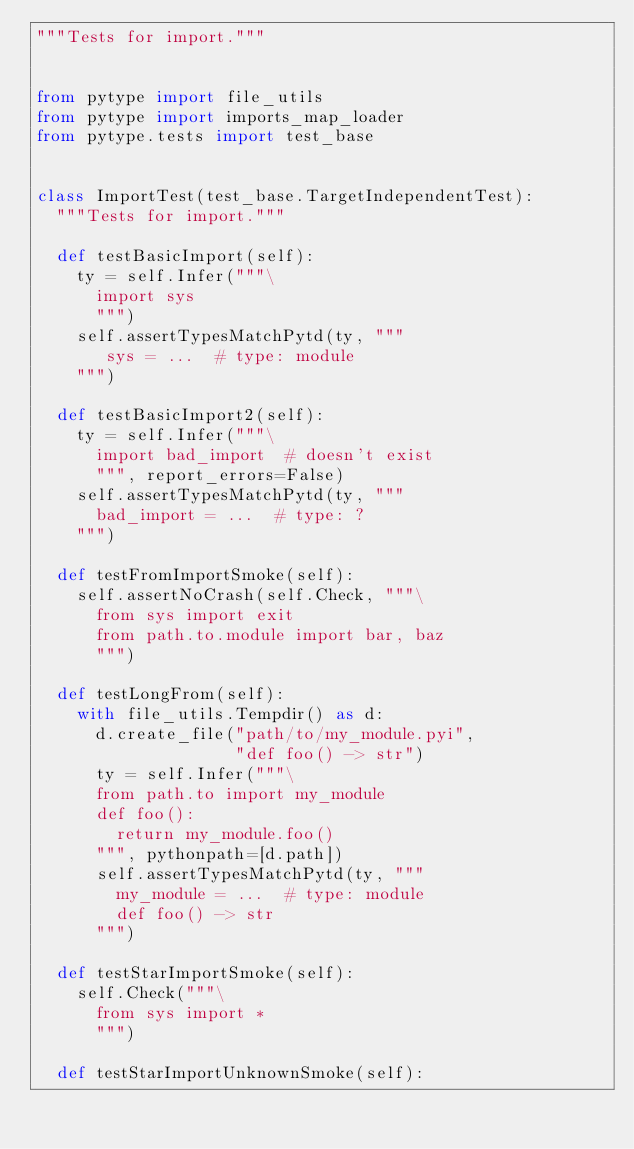<code> <loc_0><loc_0><loc_500><loc_500><_Python_>"""Tests for import."""


from pytype import file_utils
from pytype import imports_map_loader
from pytype.tests import test_base


class ImportTest(test_base.TargetIndependentTest):
  """Tests for import."""

  def testBasicImport(self):
    ty = self.Infer("""\
      import sys
      """)
    self.assertTypesMatchPytd(ty, """
       sys = ...  # type: module
    """)

  def testBasicImport2(self):
    ty = self.Infer("""\
      import bad_import  # doesn't exist
      """, report_errors=False)
    self.assertTypesMatchPytd(ty, """
      bad_import = ...  # type: ?
    """)

  def testFromImportSmoke(self):
    self.assertNoCrash(self.Check, """\
      from sys import exit
      from path.to.module import bar, baz
      """)

  def testLongFrom(self):
    with file_utils.Tempdir() as d:
      d.create_file("path/to/my_module.pyi",
                    "def foo() -> str")
      ty = self.Infer("""\
      from path.to import my_module
      def foo():
        return my_module.foo()
      """, pythonpath=[d.path])
      self.assertTypesMatchPytd(ty, """
        my_module = ...  # type: module
        def foo() -> str
      """)

  def testStarImportSmoke(self):
    self.Check("""\
      from sys import *
      """)

  def testStarImportUnknownSmoke(self):</code> 